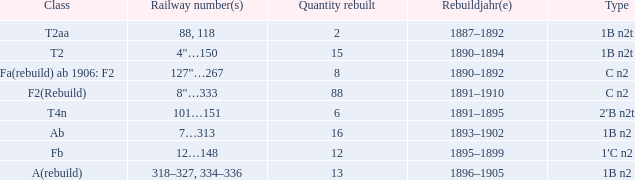Write the full table. {'header': ['Class', 'Railway number(s)', 'Quantity rebuilt', 'Rebuildjahr(e)', 'Type'], 'rows': [['T2aa', '88, 118', '2', '1887–1892', '1B n2t'], ['T2', '4"…150', '15', '1890–1894', '1B n2t'], ['Fa(rebuild) ab 1906: F2', '127"…267', '8', '1890–1892', 'C n2'], ['F2(Rebuild)', '8"…333', '88', '1891–1910', 'C n2'], ['T4n', '101…151', '6', '1891–1895', '2′B n2t'], ['Ab', '7…313', '16', '1893–1902', '1B n2'], ['Fb', '12…148', '12', '1895–1899', '1′C n2'], ['A(rebuild)', '318–327, 334–336', '13', '1896–1905', '1B n2']]} What is the reconstruction year for the t2aa class? 1887–1892. 